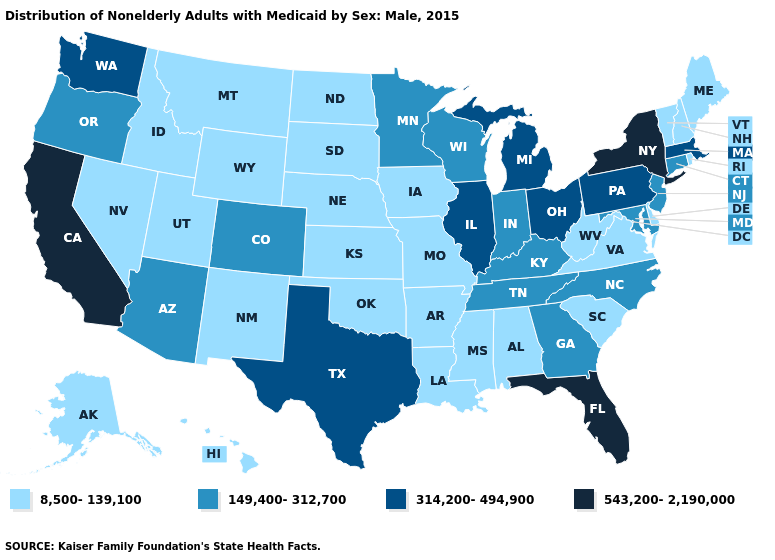Does Indiana have a lower value than Minnesota?
Give a very brief answer. No. What is the lowest value in the West?
Write a very short answer. 8,500-139,100. Does Nebraska have the same value as Oklahoma?
Short answer required. Yes. Name the states that have a value in the range 149,400-312,700?
Write a very short answer. Arizona, Colorado, Connecticut, Georgia, Indiana, Kentucky, Maryland, Minnesota, New Jersey, North Carolina, Oregon, Tennessee, Wisconsin. What is the value of Arkansas?
Keep it brief. 8,500-139,100. Name the states that have a value in the range 8,500-139,100?
Keep it brief. Alabama, Alaska, Arkansas, Delaware, Hawaii, Idaho, Iowa, Kansas, Louisiana, Maine, Mississippi, Missouri, Montana, Nebraska, Nevada, New Hampshire, New Mexico, North Dakota, Oklahoma, Rhode Island, South Carolina, South Dakota, Utah, Vermont, Virginia, West Virginia, Wyoming. Which states have the lowest value in the USA?
Be succinct. Alabama, Alaska, Arkansas, Delaware, Hawaii, Idaho, Iowa, Kansas, Louisiana, Maine, Mississippi, Missouri, Montana, Nebraska, Nevada, New Hampshire, New Mexico, North Dakota, Oklahoma, Rhode Island, South Carolina, South Dakota, Utah, Vermont, Virginia, West Virginia, Wyoming. What is the value of Connecticut?
Give a very brief answer. 149,400-312,700. What is the value of Missouri?
Concise answer only. 8,500-139,100. Which states hav the highest value in the South?
Write a very short answer. Florida. Among the states that border Massachusetts , does New York have the highest value?
Give a very brief answer. Yes. Name the states that have a value in the range 149,400-312,700?
Concise answer only. Arizona, Colorado, Connecticut, Georgia, Indiana, Kentucky, Maryland, Minnesota, New Jersey, North Carolina, Oregon, Tennessee, Wisconsin. What is the value of Colorado?
Short answer required. 149,400-312,700. Does Oregon have the lowest value in the West?
Concise answer only. No. 